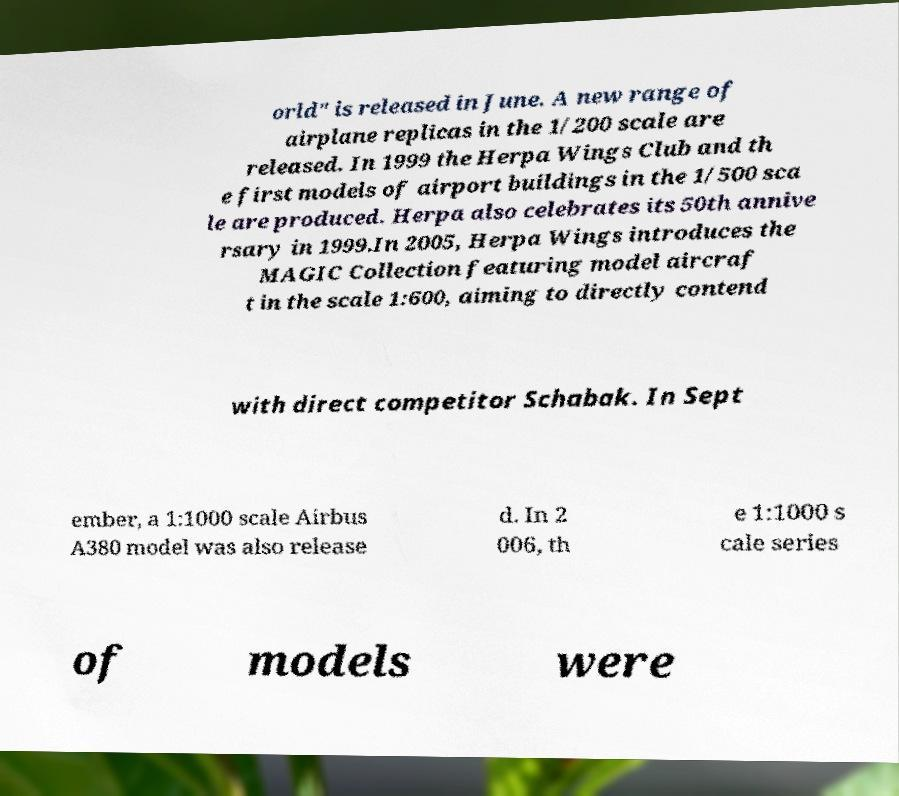Can you read and provide the text displayed in the image?This photo seems to have some interesting text. Can you extract and type it out for me? orld" is released in June. A new range of airplane replicas in the 1/200 scale are released. In 1999 the Herpa Wings Club and th e first models of airport buildings in the 1/500 sca le are produced. Herpa also celebrates its 50th annive rsary in 1999.In 2005, Herpa Wings introduces the MAGIC Collection featuring model aircraf t in the scale 1:600, aiming to directly contend with direct competitor Schabak. In Sept ember, a 1:1000 scale Airbus A380 model was also release d. In 2 006, th e 1:1000 s cale series of models were 